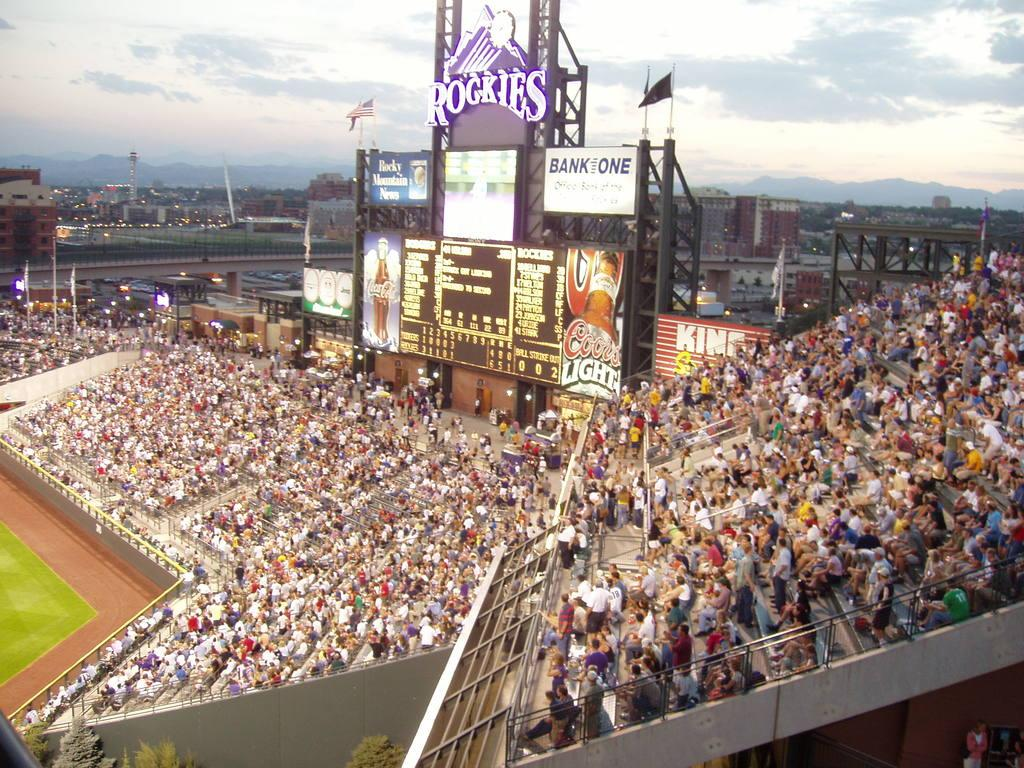<image>
Summarize the visual content of the image. People attending a baseball game at the Rockies stadium 